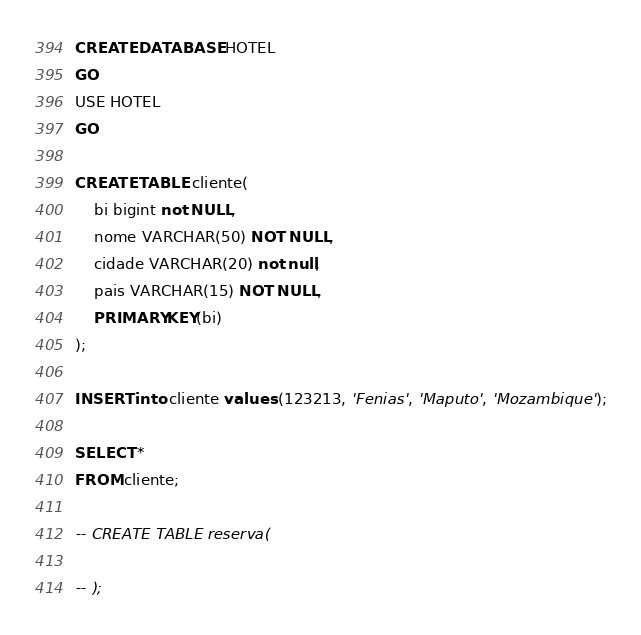<code> <loc_0><loc_0><loc_500><loc_500><_SQL_>CREATE DATABASE HOTEL
GO
USE HOTEL
GO

CREATE TABLE cliente(
    bi bigint not NULL,
    nome VARCHAR(50) NOT NULL,
    cidade VARCHAR(20) not null,
    pais VARCHAR(15) NOT NULL,
    PRIMARY KEY(bi)
);

INSERT into cliente values (123213, 'Fenias', 'Maputo', 'Mozambique');

SELECT *
FROM cliente;

-- CREATE TABLE reserva(

-- );
</code> 